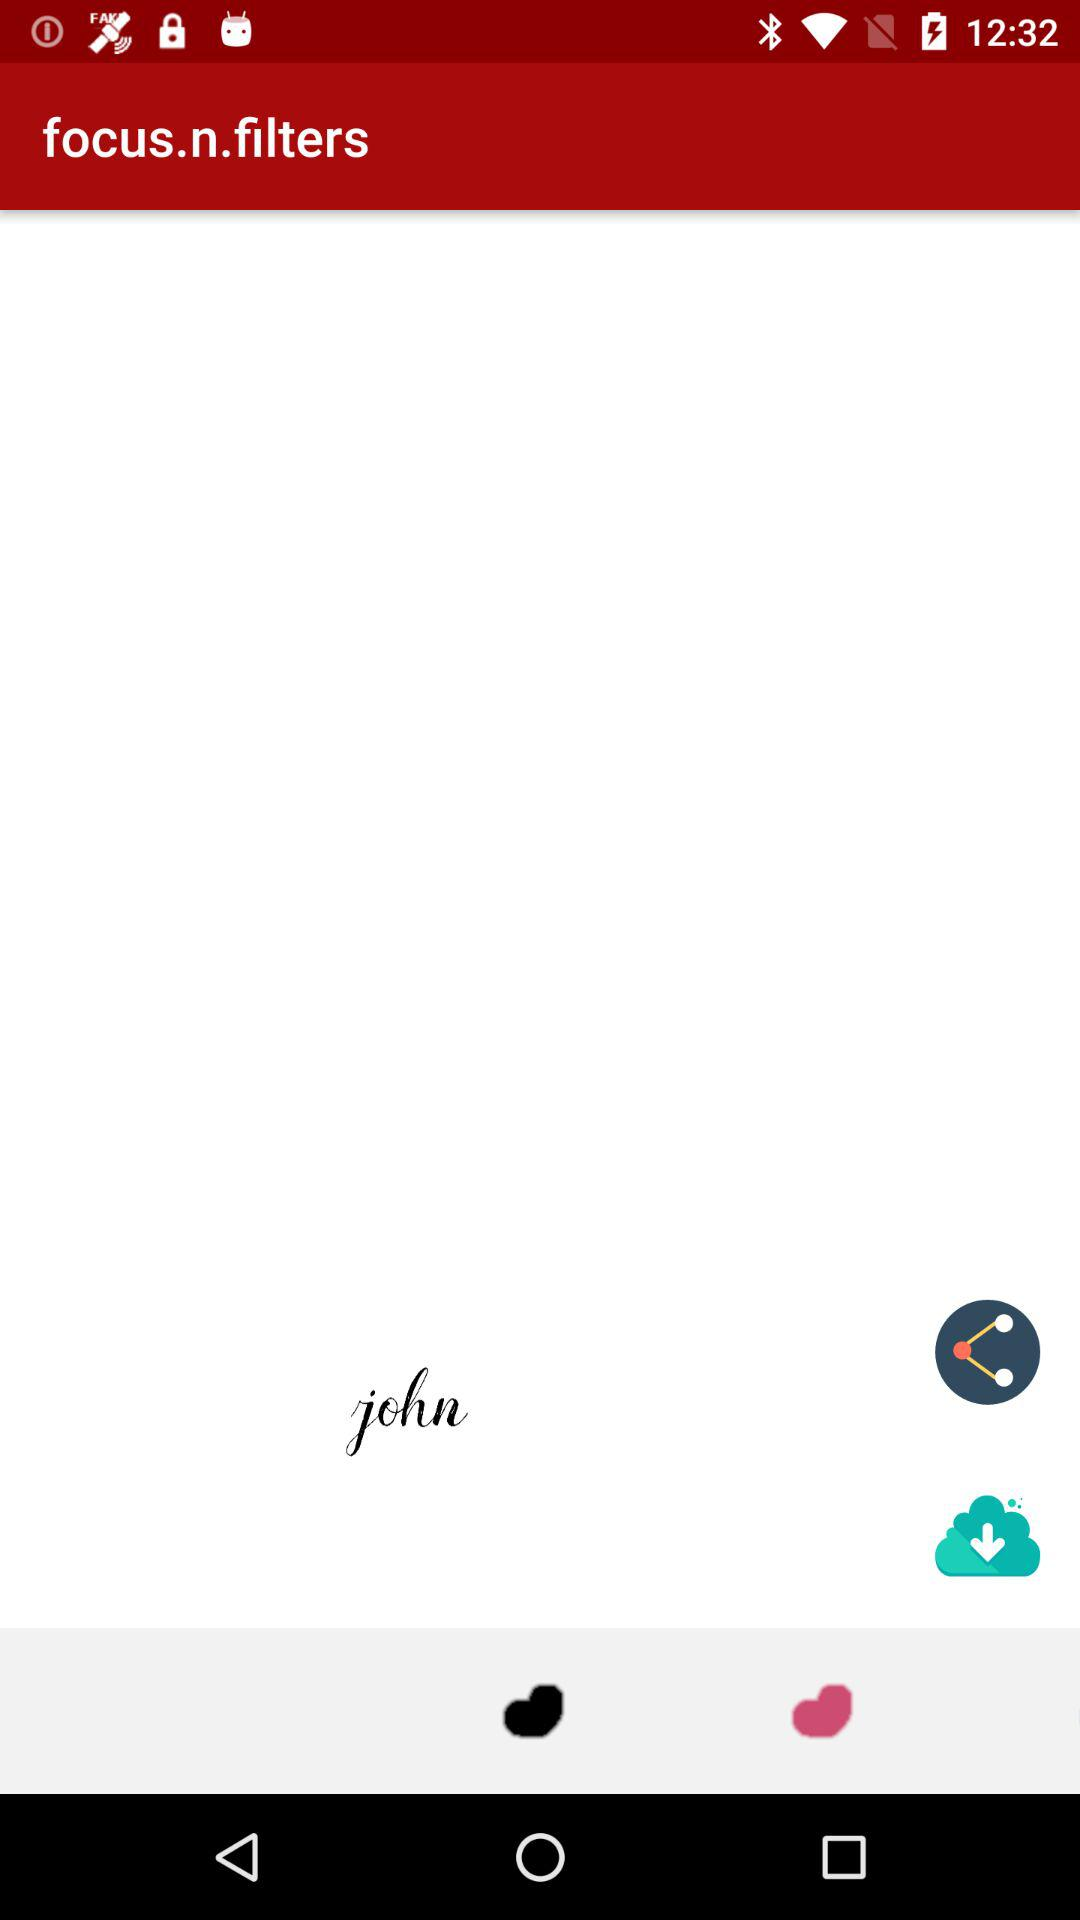How many images have been downloaded?
When the provided information is insufficient, respond with <no answer>. <no answer> 